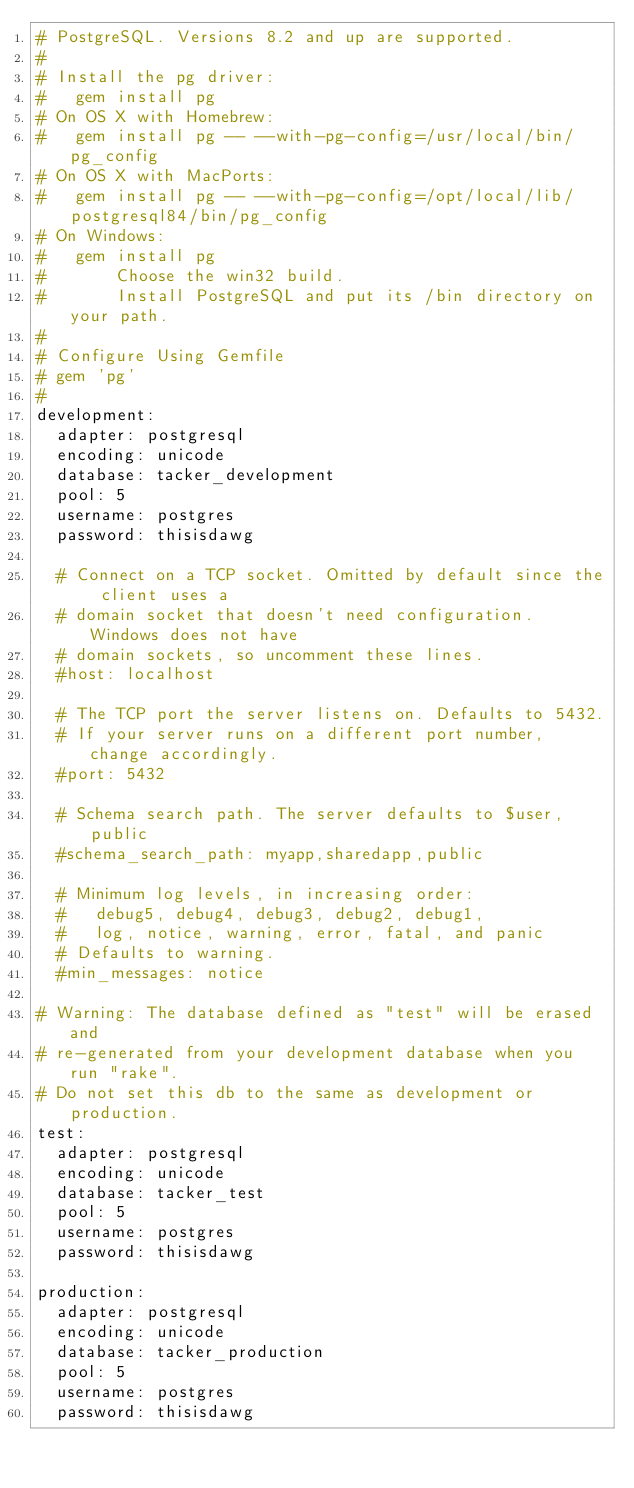<code> <loc_0><loc_0><loc_500><loc_500><_YAML_># PostgreSQL. Versions 8.2 and up are supported.
#
# Install the pg driver:
#   gem install pg
# On OS X with Homebrew:
#   gem install pg -- --with-pg-config=/usr/local/bin/pg_config
# On OS X with MacPorts:
#   gem install pg -- --with-pg-config=/opt/local/lib/postgresql84/bin/pg_config
# On Windows:
#   gem install pg
#       Choose the win32 build.
#       Install PostgreSQL and put its /bin directory on your path.
#
# Configure Using Gemfile
# gem 'pg'
#
development:
  adapter: postgresql
  encoding: unicode
  database: tacker_development
  pool: 5
  username: postgres
  password: thisisdawg

  # Connect on a TCP socket. Omitted by default since the client uses a
  # domain socket that doesn't need configuration. Windows does not have
  # domain sockets, so uncomment these lines.
  #host: localhost

  # The TCP port the server listens on. Defaults to 5432.
  # If your server runs on a different port number, change accordingly.
  #port: 5432

  # Schema search path. The server defaults to $user,public
  #schema_search_path: myapp,sharedapp,public

  # Minimum log levels, in increasing order:
  #   debug5, debug4, debug3, debug2, debug1,
  #   log, notice, warning, error, fatal, and panic
  # Defaults to warning.
  #min_messages: notice

# Warning: The database defined as "test" will be erased and
# re-generated from your development database when you run "rake".
# Do not set this db to the same as development or production.
test:
  adapter: postgresql
  encoding: unicode
  database: tacker_test
  pool: 5
  username: postgres
  password: thisisdawg

production:
  adapter: postgresql
  encoding: unicode
  database: tacker_production
  pool: 5
  username: postgres
  password: thisisdawg
</code> 